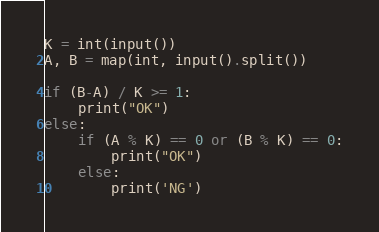<code> <loc_0><loc_0><loc_500><loc_500><_Python_>K = int(input())
A, B = map(int, input().split())

if (B-A) / K >= 1:
    print("OK")
else:
    if (A % K) == 0 or (B % K) == 0:
        print("OK")
    else:
        print('NG')</code> 